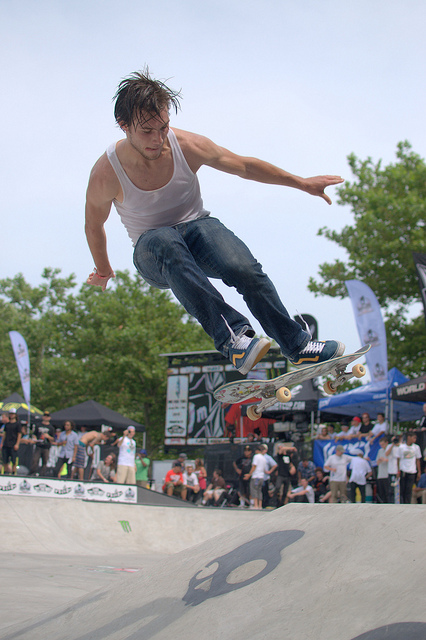<image>What is the name of this skate park? The name of the skate park is not clear. It could be "van's", "supadupaskatenstuff", "john", "thrills", "park", "vans", "skate", "skate", or "freestyle". What is the name of this skate park? I don't know the name of this skate park. It can be 'van's', 'supadupaskatenstuff', 'john', 'thrills', 'park', 'vans', 'skate', 'freestyle', or unknown. 